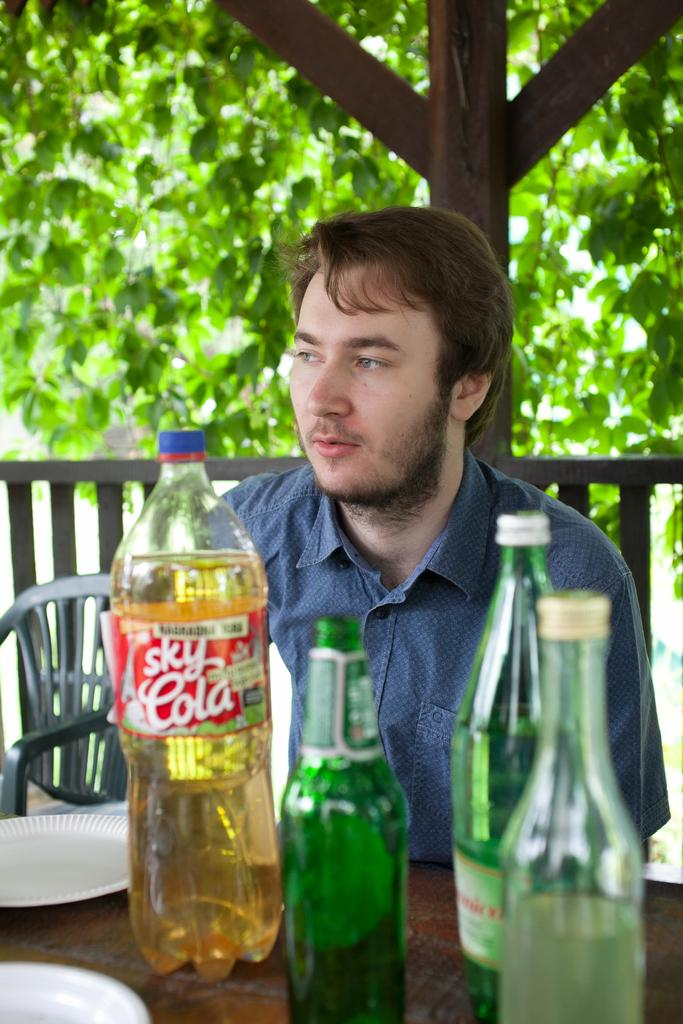Provide a one-sentence caption for the provided image. A man is sitting next to some bottles and one is labeled "Sky Cola". 